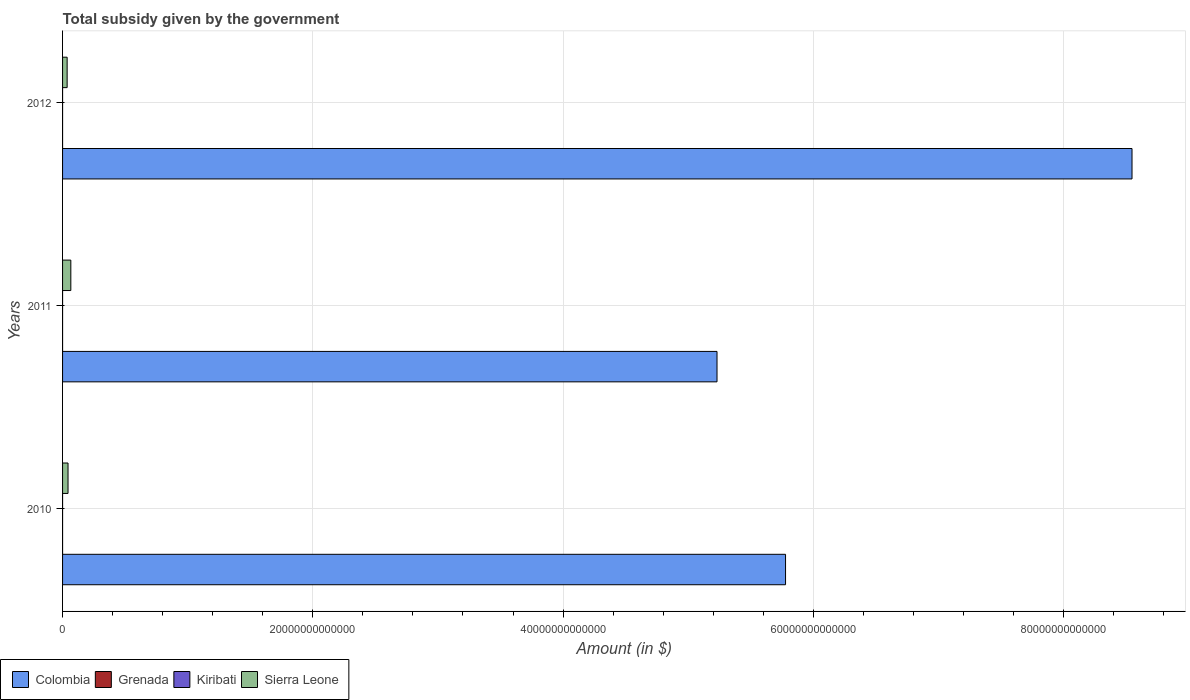How many groups of bars are there?
Offer a terse response. 3. Are the number of bars per tick equal to the number of legend labels?
Your answer should be very brief. Yes. Are the number of bars on each tick of the Y-axis equal?
Offer a terse response. Yes. How many bars are there on the 1st tick from the bottom?
Give a very brief answer. 4. What is the label of the 1st group of bars from the top?
Provide a succinct answer. 2012. What is the total revenue collected by the government in Sierra Leone in 2010?
Provide a succinct answer. 4.37e+11. Across all years, what is the maximum total revenue collected by the government in Grenada?
Make the answer very short. 7.42e+07. Across all years, what is the minimum total revenue collected by the government in Colombia?
Your response must be concise. 5.23e+13. What is the total total revenue collected by the government in Kiribati in the graph?
Offer a terse response. 2.98e+07. What is the difference between the total revenue collected by the government in Colombia in 2011 and that in 2012?
Ensure brevity in your answer.  -3.32e+13. What is the difference between the total revenue collected by the government in Kiribati in 2010 and the total revenue collected by the government in Sierra Leone in 2012?
Make the answer very short. -3.66e+11. What is the average total revenue collected by the government in Colombia per year?
Provide a succinct answer. 6.52e+13. In the year 2011, what is the difference between the total revenue collected by the government in Colombia and total revenue collected by the government in Kiribati?
Ensure brevity in your answer.  5.23e+13. In how many years, is the total revenue collected by the government in Grenada greater than 52000000000000 $?
Make the answer very short. 0. What is the ratio of the total revenue collected by the government in Sierra Leone in 2010 to that in 2012?
Give a very brief answer. 1.19. Is the difference between the total revenue collected by the government in Colombia in 2011 and 2012 greater than the difference between the total revenue collected by the government in Kiribati in 2011 and 2012?
Your answer should be very brief. No. What is the difference between the highest and the second highest total revenue collected by the government in Kiribati?
Your response must be concise. 4.91e+06. What is the difference between the highest and the lowest total revenue collected by the government in Grenada?
Keep it short and to the point. 3.30e+06. In how many years, is the total revenue collected by the government in Kiribati greater than the average total revenue collected by the government in Kiribati taken over all years?
Provide a short and direct response. 1. Is it the case that in every year, the sum of the total revenue collected by the government in Grenada and total revenue collected by the government in Colombia is greater than the sum of total revenue collected by the government in Sierra Leone and total revenue collected by the government in Kiribati?
Make the answer very short. Yes. What does the 3rd bar from the top in 2010 represents?
Provide a short and direct response. Grenada. What does the 3rd bar from the bottom in 2010 represents?
Your response must be concise. Kiribati. Is it the case that in every year, the sum of the total revenue collected by the government in Kiribati and total revenue collected by the government in Colombia is greater than the total revenue collected by the government in Grenada?
Provide a succinct answer. Yes. Are all the bars in the graph horizontal?
Give a very brief answer. Yes. What is the difference between two consecutive major ticks on the X-axis?
Provide a succinct answer. 2.00e+13. Does the graph contain any zero values?
Offer a very short reply. No. Does the graph contain grids?
Offer a terse response. Yes. How many legend labels are there?
Give a very brief answer. 4. How are the legend labels stacked?
Provide a short and direct response. Horizontal. What is the title of the graph?
Offer a very short reply. Total subsidy given by the government. What is the label or title of the X-axis?
Ensure brevity in your answer.  Amount (in $). What is the label or title of the Y-axis?
Your answer should be very brief. Years. What is the Amount (in $) of Colombia in 2010?
Make the answer very short. 5.78e+13. What is the Amount (in $) of Grenada in 2010?
Provide a succinct answer. 7.42e+07. What is the Amount (in $) in Kiribati in 2010?
Your answer should be very brief. 9.01e+06. What is the Amount (in $) of Sierra Leone in 2010?
Provide a succinct answer. 4.37e+11. What is the Amount (in $) of Colombia in 2011?
Make the answer very short. 5.23e+13. What is the Amount (in $) in Grenada in 2011?
Offer a terse response. 7.24e+07. What is the Amount (in $) in Kiribati in 2011?
Ensure brevity in your answer.  1.39e+07. What is the Amount (in $) of Sierra Leone in 2011?
Give a very brief answer. 6.61e+11. What is the Amount (in $) in Colombia in 2012?
Make the answer very short. 8.55e+13. What is the Amount (in $) of Grenada in 2012?
Offer a terse response. 7.09e+07. What is the Amount (in $) in Kiribati in 2012?
Keep it short and to the point. 6.83e+06. What is the Amount (in $) in Sierra Leone in 2012?
Offer a terse response. 3.66e+11. Across all years, what is the maximum Amount (in $) of Colombia?
Make the answer very short. 8.55e+13. Across all years, what is the maximum Amount (in $) of Grenada?
Provide a succinct answer. 7.42e+07. Across all years, what is the maximum Amount (in $) in Kiribati?
Your response must be concise. 1.39e+07. Across all years, what is the maximum Amount (in $) in Sierra Leone?
Your answer should be very brief. 6.61e+11. Across all years, what is the minimum Amount (in $) in Colombia?
Give a very brief answer. 5.23e+13. Across all years, what is the minimum Amount (in $) of Grenada?
Ensure brevity in your answer.  7.09e+07. Across all years, what is the minimum Amount (in $) of Kiribati?
Your answer should be very brief. 6.83e+06. Across all years, what is the minimum Amount (in $) of Sierra Leone?
Your answer should be very brief. 3.66e+11. What is the total Amount (in $) of Colombia in the graph?
Offer a very short reply. 1.96e+14. What is the total Amount (in $) of Grenada in the graph?
Your answer should be compact. 2.18e+08. What is the total Amount (in $) in Kiribati in the graph?
Give a very brief answer. 2.98e+07. What is the total Amount (in $) of Sierra Leone in the graph?
Your answer should be very brief. 1.46e+12. What is the difference between the Amount (in $) in Colombia in 2010 and that in 2011?
Ensure brevity in your answer.  5.48e+12. What is the difference between the Amount (in $) of Grenada in 2010 and that in 2011?
Your answer should be compact. 1.80e+06. What is the difference between the Amount (in $) of Kiribati in 2010 and that in 2011?
Your response must be concise. -4.91e+06. What is the difference between the Amount (in $) of Sierra Leone in 2010 and that in 2011?
Provide a succinct answer. -2.24e+11. What is the difference between the Amount (in $) in Colombia in 2010 and that in 2012?
Provide a short and direct response. -2.77e+13. What is the difference between the Amount (in $) of Grenada in 2010 and that in 2012?
Keep it short and to the point. 3.30e+06. What is the difference between the Amount (in $) in Kiribati in 2010 and that in 2012?
Your answer should be compact. 2.17e+06. What is the difference between the Amount (in $) of Sierra Leone in 2010 and that in 2012?
Your response must be concise. 7.06e+1. What is the difference between the Amount (in $) of Colombia in 2011 and that in 2012?
Your response must be concise. -3.32e+13. What is the difference between the Amount (in $) in Grenada in 2011 and that in 2012?
Make the answer very short. 1.50e+06. What is the difference between the Amount (in $) of Kiribati in 2011 and that in 2012?
Your answer should be compact. 7.08e+06. What is the difference between the Amount (in $) in Sierra Leone in 2011 and that in 2012?
Offer a terse response. 2.94e+11. What is the difference between the Amount (in $) of Colombia in 2010 and the Amount (in $) of Grenada in 2011?
Your answer should be compact. 5.78e+13. What is the difference between the Amount (in $) of Colombia in 2010 and the Amount (in $) of Kiribati in 2011?
Ensure brevity in your answer.  5.78e+13. What is the difference between the Amount (in $) of Colombia in 2010 and the Amount (in $) of Sierra Leone in 2011?
Offer a very short reply. 5.71e+13. What is the difference between the Amount (in $) of Grenada in 2010 and the Amount (in $) of Kiribati in 2011?
Give a very brief answer. 6.03e+07. What is the difference between the Amount (in $) in Grenada in 2010 and the Amount (in $) in Sierra Leone in 2011?
Give a very brief answer. -6.61e+11. What is the difference between the Amount (in $) of Kiribati in 2010 and the Amount (in $) of Sierra Leone in 2011?
Give a very brief answer. -6.61e+11. What is the difference between the Amount (in $) of Colombia in 2010 and the Amount (in $) of Grenada in 2012?
Provide a short and direct response. 5.78e+13. What is the difference between the Amount (in $) in Colombia in 2010 and the Amount (in $) in Kiribati in 2012?
Your answer should be very brief. 5.78e+13. What is the difference between the Amount (in $) in Colombia in 2010 and the Amount (in $) in Sierra Leone in 2012?
Give a very brief answer. 5.74e+13. What is the difference between the Amount (in $) in Grenada in 2010 and the Amount (in $) in Kiribati in 2012?
Give a very brief answer. 6.74e+07. What is the difference between the Amount (in $) of Grenada in 2010 and the Amount (in $) of Sierra Leone in 2012?
Your response must be concise. -3.66e+11. What is the difference between the Amount (in $) in Kiribati in 2010 and the Amount (in $) in Sierra Leone in 2012?
Your answer should be very brief. -3.66e+11. What is the difference between the Amount (in $) of Colombia in 2011 and the Amount (in $) of Grenada in 2012?
Your response must be concise. 5.23e+13. What is the difference between the Amount (in $) of Colombia in 2011 and the Amount (in $) of Kiribati in 2012?
Your response must be concise. 5.23e+13. What is the difference between the Amount (in $) in Colombia in 2011 and the Amount (in $) in Sierra Leone in 2012?
Give a very brief answer. 5.19e+13. What is the difference between the Amount (in $) in Grenada in 2011 and the Amount (in $) in Kiribati in 2012?
Give a very brief answer. 6.56e+07. What is the difference between the Amount (in $) in Grenada in 2011 and the Amount (in $) in Sierra Leone in 2012?
Your answer should be very brief. -3.66e+11. What is the difference between the Amount (in $) in Kiribati in 2011 and the Amount (in $) in Sierra Leone in 2012?
Offer a terse response. -3.66e+11. What is the average Amount (in $) in Colombia per year?
Give a very brief answer. 6.52e+13. What is the average Amount (in $) of Grenada per year?
Make the answer very short. 7.25e+07. What is the average Amount (in $) of Kiribati per year?
Your answer should be compact. 9.92e+06. What is the average Amount (in $) of Sierra Leone per year?
Your response must be concise. 4.88e+11. In the year 2010, what is the difference between the Amount (in $) of Colombia and Amount (in $) of Grenada?
Make the answer very short. 5.78e+13. In the year 2010, what is the difference between the Amount (in $) in Colombia and Amount (in $) in Kiribati?
Provide a short and direct response. 5.78e+13. In the year 2010, what is the difference between the Amount (in $) in Colombia and Amount (in $) in Sierra Leone?
Make the answer very short. 5.73e+13. In the year 2010, what is the difference between the Amount (in $) in Grenada and Amount (in $) in Kiribati?
Keep it short and to the point. 6.52e+07. In the year 2010, what is the difference between the Amount (in $) of Grenada and Amount (in $) of Sierra Leone?
Make the answer very short. -4.37e+11. In the year 2010, what is the difference between the Amount (in $) in Kiribati and Amount (in $) in Sierra Leone?
Your response must be concise. -4.37e+11. In the year 2011, what is the difference between the Amount (in $) in Colombia and Amount (in $) in Grenada?
Keep it short and to the point. 5.23e+13. In the year 2011, what is the difference between the Amount (in $) in Colombia and Amount (in $) in Kiribati?
Your answer should be compact. 5.23e+13. In the year 2011, what is the difference between the Amount (in $) of Colombia and Amount (in $) of Sierra Leone?
Your answer should be compact. 5.16e+13. In the year 2011, what is the difference between the Amount (in $) of Grenada and Amount (in $) of Kiribati?
Ensure brevity in your answer.  5.85e+07. In the year 2011, what is the difference between the Amount (in $) in Grenada and Amount (in $) in Sierra Leone?
Offer a very short reply. -6.61e+11. In the year 2011, what is the difference between the Amount (in $) in Kiribati and Amount (in $) in Sierra Leone?
Provide a short and direct response. -6.61e+11. In the year 2012, what is the difference between the Amount (in $) in Colombia and Amount (in $) in Grenada?
Your answer should be very brief. 8.55e+13. In the year 2012, what is the difference between the Amount (in $) in Colombia and Amount (in $) in Kiribati?
Give a very brief answer. 8.55e+13. In the year 2012, what is the difference between the Amount (in $) of Colombia and Amount (in $) of Sierra Leone?
Make the answer very short. 8.51e+13. In the year 2012, what is the difference between the Amount (in $) of Grenada and Amount (in $) of Kiribati?
Ensure brevity in your answer.  6.41e+07. In the year 2012, what is the difference between the Amount (in $) of Grenada and Amount (in $) of Sierra Leone?
Keep it short and to the point. -3.66e+11. In the year 2012, what is the difference between the Amount (in $) in Kiribati and Amount (in $) in Sierra Leone?
Provide a short and direct response. -3.66e+11. What is the ratio of the Amount (in $) in Colombia in 2010 to that in 2011?
Give a very brief answer. 1.1. What is the ratio of the Amount (in $) of Grenada in 2010 to that in 2011?
Make the answer very short. 1.02. What is the ratio of the Amount (in $) of Kiribati in 2010 to that in 2011?
Provide a succinct answer. 0.65. What is the ratio of the Amount (in $) of Sierra Leone in 2010 to that in 2011?
Provide a short and direct response. 0.66. What is the ratio of the Amount (in $) in Colombia in 2010 to that in 2012?
Offer a very short reply. 0.68. What is the ratio of the Amount (in $) in Grenada in 2010 to that in 2012?
Offer a terse response. 1.05. What is the ratio of the Amount (in $) of Kiribati in 2010 to that in 2012?
Keep it short and to the point. 1.32. What is the ratio of the Amount (in $) of Sierra Leone in 2010 to that in 2012?
Keep it short and to the point. 1.19. What is the ratio of the Amount (in $) in Colombia in 2011 to that in 2012?
Provide a succinct answer. 0.61. What is the ratio of the Amount (in $) in Grenada in 2011 to that in 2012?
Give a very brief answer. 1.02. What is the ratio of the Amount (in $) of Kiribati in 2011 to that in 2012?
Offer a very short reply. 2.04. What is the ratio of the Amount (in $) in Sierra Leone in 2011 to that in 2012?
Ensure brevity in your answer.  1.8. What is the difference between the highest and the second highest Amount (in $) in Colombia?
Give a very brief answer. 2.77e+13. What is the difference between the highest and the second highest Amount (in $) in Grenada?
Your response must be concise. 1.80e+06. What is the difference between the highest and the second highest Amount (in $) of Kiribati?
Your answer should be compact. 4.91e+06. What is the difference between the highest and the second highest Amount (in $) in Sierra Leone?
Your response must be concise. 2.24e+11. What is the difference between the highest and the lowest Amount (in $) of Colombia?
Your answer should be very brief. 3.32e+13. What is the difference between the highest and the lowest Amount (in $) in Grenada?
Provide a succinct answer. 3.30e+06. What is the difference between the highest and the lowest Amount (in $) in Kiribati?
Offer a terse response. 7.08e+06. What is the difference between the highest and the lowest Amount (in $) in Sierra Leone?
Offer a terse response. 2.94e+11. 